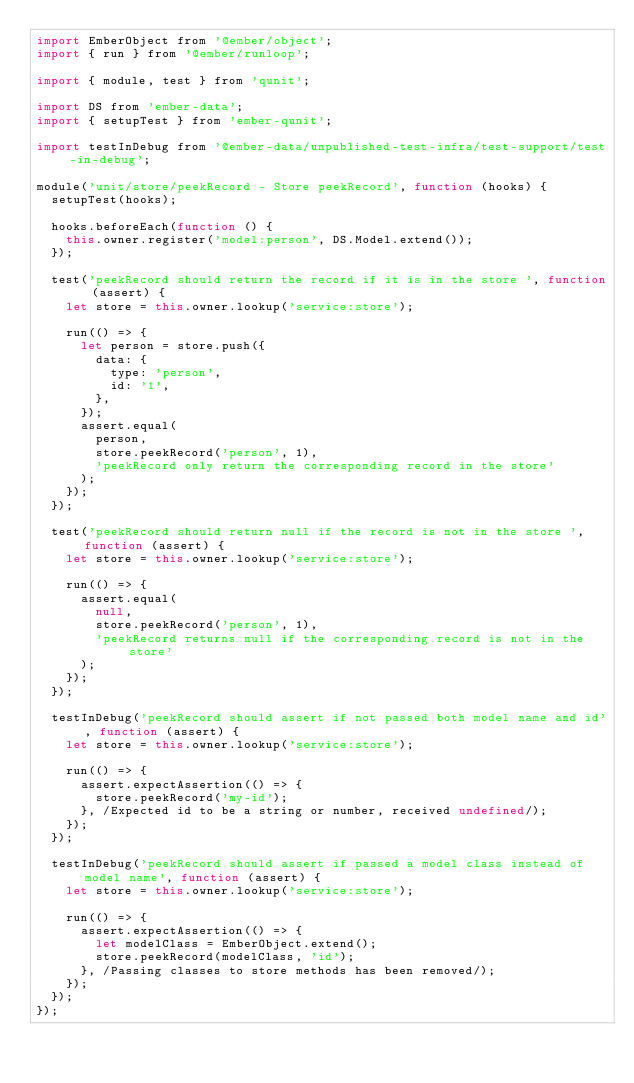<code> <loc_0><loc_0><loc_500><loc_500><_JavaScript_>import EmberObject from '@ember/object';
import { run } from '@ember/runloop';

import { module, test } from 'qunit';

import DS from 'ember-data';
import { setupTest } from 'ember-qunit';

import testInDebug from '@ember-data/unpublished-test-infra/test-support/test-in-debug';

module('unit/store/peekRecord - Store peekRecord', function (hooks) {
  setupTest(hooks);

  hooks.beforeEach(function () {
    this.owner.register('model:person', DS.Model.extend());
  });

  test('peekRecord should return the record if it is in the store ', function (assert) {
    let store = this.owner.lookup('service:store');

    run(() => {
      let person = store.push({
        data: {
          type: 'person',
          id: '1',
        },
      });
      assert.equal(
        person,
        store.peekRecord('person', 1),
        'peekRecord only return the corresponding record in the store'
      );
    });
  });

  test('peekRecord should return null if the record is not in the store ', function (assert) {
    let store = this.owner.lookup('service:store');

    run(() => {
      assert.equal(
        null,
        store.peekRecord('person', 1),
        'peekRecord returns null if the corresponding record is not in the store'
      );
    });
  });

  testInDebug('peekRecord should assert if not passed both model name and id', function (assert) {
    let store = this.owner.lookup('service:store');

    run(() => {
      assert.expectAssertion(() => {
        store.peekRecord('my-id');
      }, /Expected id to be a string or number, received undefined/);
    });
  });

  testInDebug('peekRecord should assert if passed a model class instead of model name', function (assert) {
    let store = this.owner.lookup('service:store');

    run(() => {
      assert.expectAssertion(() => {
        let modelClass = EmberObject.extend();
        store.peekRecord(modelClass, 'id');
      }, /Passing classes to store methods has been removed/);
    });
  });
});
</code> 